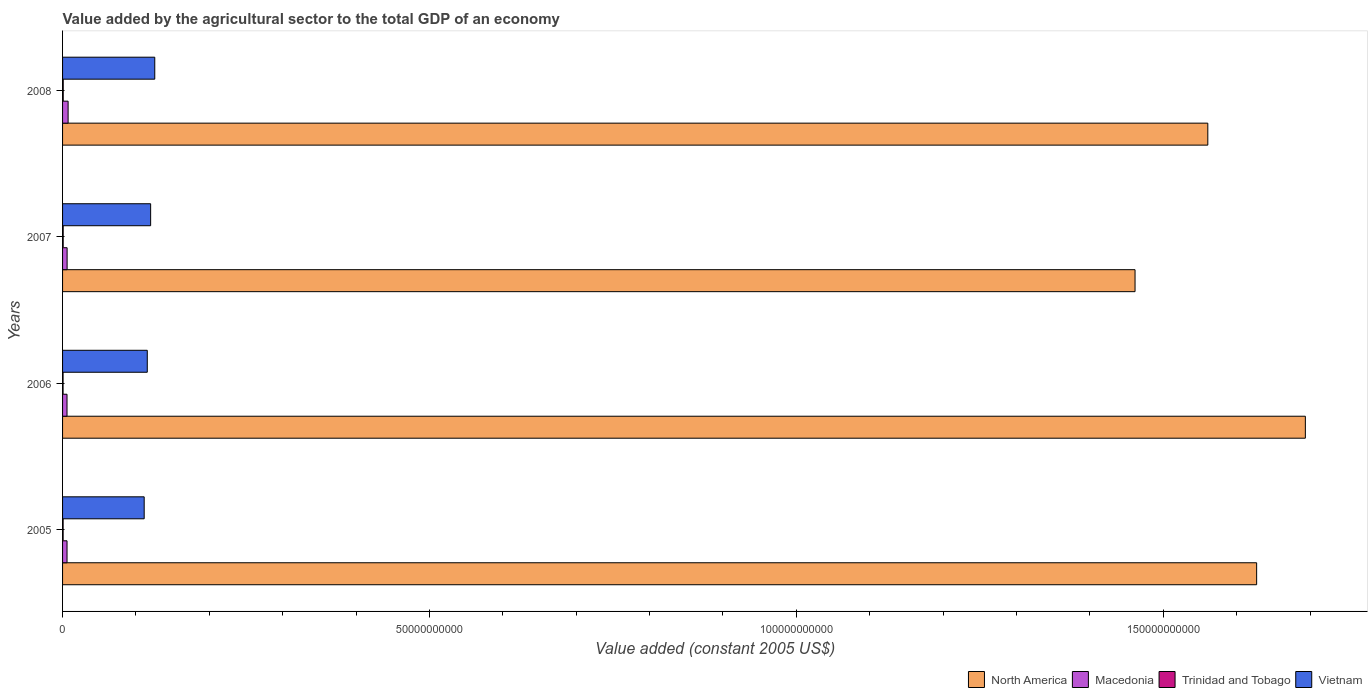How many groups of bars are there?
Keep it short and to the point. 4. Are the number of bars on each tick of the Y-axis equal?
Provide a short and direct response. Yes. How many bars are there on the 3rd tick from the bottom?
Offer a very short reply. 4. What is the label of the 4th group of bars from the top?
Your answer should be very brief. 2005. What is the value added by the agricultural sector in Vietnam in 2008?
Ensure brevity in your answer.  1.26e+1. Across all years, what is the maximum value added by the agricultural sector in Trinidad and Tobago?
Provide a succinct answer. 9.12e+07. Across all years, what is the minimum value added by the agricultural sector in Macedonia?
Keep it short and to the point. 6.06e+08. What is the total value added by the agricultural sector in Trinidad and Tobago in the graph?
Provide a succinct answer. 3.23e+08. What is the difference between the value added by the agricultural sector in Trinidad and Tobago in 2005 and that in 2008?
Provide a short and direct response. -1.39e+07. What is the difference between the value added by the agricultural sector in North America in 2006 and the value added by the agricultural sector in Trinidad and Tobago in 2008?
Your response must be concise. 1.69e+11. What is the average value added by the agricultural sector in Trinidad and Tobago per year?
Your response must be concise. 8.07e+07. In the year 2007, what is the difference between the value added by the agricultural sector in Trinidad and Tobago and value added by the agricultural sector in Vietnam?
Your answer should be compact. -1.19e+1. In how many years, is the value added by the agricultural sector in Trinidad and Tobago greater than 80000000000 US$?
Keep it short and to the point. 0. What is the ratio of the value added by the agricultural sector in North America in 2005 to that in 2007?
Offer a very short reply. 1.11. Is the value added by the agricultural sector in Macedonia in 2005 less than that in 2007?
Keep it short and to the point. Yes. What is the difference between the highest and the second highest value added by the agricultural sector in North America?
Offer a terse response. 6.64e+09. What is the difference between the highest and the lowest value added by the agricultural sector in Macedonia?
Offer a terse response. 1.49e+08. In how many years, is the value added by the agricultural sector in North America greater than the average value added by the agricultural sector in North America taken over all years?
Give a very brief answer. 2. Is the sum of the value added by the agricultural sector in Vietnam in 2006 and 2008 greater than the maximum value added by the agricultural sector in North America across all years?
Give a very brief answer. No. What does the 2nd bar from the top in 2006 represents?
Your answer should be very brief. Trinidad and Tobago. What does the 3rd bar from the bottom in 2008 represents?
Give a very brief answer. Trinidad and Tobago. Is it the case that in every year, the sum of the value added by the agricultural sector in North America and value added by the agricultural sector in Macedonia is greater than the value added by the agricultural sector in Trinidad and Tobago?
Make the answer very short. Yes. How many years are there in the graph?
Provide a short and direct response. 4. What is the difference between two consecutive major ticks on the X-axis?
Offer a very short reply. 5.00e+1. Does the graph contain any zero values?
Give a very brief answer. No. Does the graph contain grids?
Make the answer very short. No. How are the legend labels stacked?
Your response must be concise. Horizontal. What is the title of the graph?
Your answer should be very brief. Value added by the agricultural sector to the total GDP of an economy. Does "Antigua and Barbuda" appear as one of the legend labels in the graph?
Offer a very short reply. No. What is the label or title of the X-axis?
Offer a terse response. Value added (constant 2005 US$). What is the label or title of the Y-axis?
Your response must be concise. Years. What is the Value added (constant 2005 US$) of North America in 2005?
Your answer should be compact. 1.63e+11. What is the Value added (constant 2005 US$) in Macedonia in 2005?
Your answer should be compact. 6.09e+08. What is the Value added (constant 2005 US$) of Trinidad and Tobago in 2005?
Offer a very short reply. 7.73e+07. What is the Value added (constant 2005 US$) of Vietnam in 2005?
Provide a succinct answer. 1.11e+1. What is the Value added (constant 2005 US$) of North America in 2006?
Your answer should be very brief. 1.69e+11. What is the Value added (constant 2005 US$) of Macedonia in 2006?
Make the answer very short. 6.06e+08. What is the Value added (constant 2005 US$) of Trinidad and Tobago in 2006?
Provide a succinct answer. 6.96e+07. What is the Value added (constant 2005 US$) of Vietnam in 2006?
Give a very brief answer. 1.15e+1. What is the Value added (constant 2005 US$) of North America in 2007?
Provide a succinct answer. 1.46e+11. What is the Value added (constant 2005 US$) of Macedonia in 2007?
Offer a terse response. 6.19e+08. What is the Value added (constant 2005 US$) in Trinidad and Tobago in 2007?
Keep it short and to the point. 8.48e+07. What is the Value added (constant 2005 US$) of Vietnam in 2007?
Your answer should be compact. 1.20e+1. What is the Value added (constant 2005 US$) in North America in 2008?
Give a very brief answer. 1.56e+11. What is the Value added (constant 2005 US$) of Macedonia in 2008?
Your response must be concise. 7.55e+08. What is the Value added (constant 2005 US$) in Trinidad and Tobago in 2008?
Offer a very short reply. 9.12e+07. What is the Value added (constant 2005 US$) of Vietnam in 2008?
Your response must be concise. 1.26e+1. Across all years, what is the maximum Value added (constant 2005 US$) in North America?
Offer a very short reply. 1.69e+11. Across all years, what is the maximum Value added (constant 2005 US$) of Macedonia?
Ensure brevity in your answer.  7.55e+08. Across all years, what is the maximum Value added (constant 2005 US$) in Trinidad and Tobago?
Your answer should be compact. 9.12e+07. Across all years, what is the maximum Value added (constant 2005 US$) in Vietnam?
Provide a succinct answer. 1.26e+1. Across all years, what is the minimum Value added (constant 2005 US$) in North America?
Offer a terse response. 1.46e+11. Across all years, what is the minimum Value added (constant 2005 US$) of Macedonia?
Keep it short and to the point. 6.06e+08. Across all years, what is the minimum Value added (constant 2005 US$) in Trinidad and Tobago?
Offer a terse response. 6.96e+07. Across all years, what is the minimum Value added (constant 2005 US$) of Vietnam?
Offer a terse response. 1.11e+1. What is the total Value added (constant 2005 US$) of North America in the graph?
Your answer should be compact. 6.34e+11. What is the total Value added (constant 2005 US$) of Macedonia in the graph?
Offer a very short reply. 2.59e+09. What is the total Value added (constant 2005 US$) of Trinidad and Tobago in the graph?
Ensure brevity in your answer.  3.23e+08. What is the total Value added (constant 2005 US$) of Vietnam in the graph?
Provide a short and direct response. 4.72e+1. What is the difference between the Value added (constant 2005 US$) of North America in 2005 and that in 2006?
Provide a short and direct response. -6.64e+09. What is the difference between the Value added (constant 2005 US$) of Macedonia in 2005 and that in 2006?
Your answer should be compact. 3.31e+06. What is the difference between the Value added (constant 2005 US$) of Trinidad and Tobago in 2005 and that in 2006?
Your response must be concise. 7.66e+06. What is the difference between the Value added (constant 2005 US$) in Vietnam in 2005 and that in 2006?
Your answer should be compact. -4.22e+08. What is the difference between the Value added (constant 2005 US$) in North America in 2005 and that in 2007?
Offer a very short reply. 1.66e+1. What is the difference between the Value added (constant 2005 US$) in Macedonia in 2005 and that in 2007?
Your answer should be very brief. -9.75e+06. What is the difference between the Value added (constant 2005 US$) of Trinidad and Tobago in 2005 and that in 2007?
Keep it short and to the point. -7.48e+06. What is the difference between the Value added (constant 2005 US$) in Vietnam in 2005 and that in 2007?
Your answer should be compact. -8.79e+08. What is the difference between the Value added (constant 2005 US$) in North America in 2005 and that in 2008?
Your answer should be very brief. 6.65e+09. What is the difference between the Value added (constant 2005 US$) in Macedonia in 2005 and that in 2008?
Offer a very short reply. -1.46e+08. What is the difference between the Value added (constant 2005 US$) in Trinidad and Tobago in 2005 and that in 2008?
Provide a short and direct response. -1.39e+07. What is the difference between the Value added (constant 2005 US$) in Vietnam in 2005 and that in 2008?
Your response must be concise. -1.44e+09. What is the difference between the Value added (constant 2005 US$) in North America in 2006 and that in 2007?
Offer a very short reply. 2.32e+1. What is the difference between the Value added (constant 2005 US$) of Macedonia in 2006 and that in 2007?
Give a very brief answer. -1.31e+07. What is the difference between the Value added (constant 2005 US$) of Trinidad and Tobago in 2006 and that in 2007?
Offer a terse response. -1.51e+07. What is the difference between the Value added (constant 2005 US$) in Vietnam in 2006 and that in 2007?
Provide a short and direct response. -4.57e+08. What is the difference between the Value added (constant 2005 US$) of North America in 2006 and that in 2008?
Offer a terse response. 1.33e+1. What is the difference between the Value added (constant 2005 US$) in Macedonia in 2006 and that in 2008?
Provide a short and direct response. -1.49e+08. What is the difference between the Value added (constant 2005 US$) in Trinidad and Tobago in 2006 and that in 2008?
Keep it short and to the point. -2.16e+07. What is the difference between the Value added (constant 2005 US$) in Vietnam in 2006 and that in 2008?
Provide a short and direct response. -1.02e+09. What is the difference between the Value added (constant 2005 US$) of North America in 2007 and that in 2008?
Ensure brevity in your answer.  -9.92e+09. What is the difference between the Value added (constant 2005 US$) of Macedonia in 2007 and that in 2008?
Provide a short and direct response. -1.36e+08. What is the difference between the Value added (constant 2005 US$) in Trinidad and Tobago in 2007 and that in 2008?
Provide a succinct answer. -6.41e+06. What is the difference between the Value added (constant 2005 US$) of Vietnam in 2007 and that in 2008?
Keep it short and to the point. -5.63e+08. What is the difference between the Value added (constant 2005 US$) in North America in 2005 and the Value added (constant 2005 US$) in Macedonia in 2006?
Your response must be concise. 1.62e+11. What is the difference between the Value added (constant 2005 US$) in North America in 2005 and the Value added (constant 2005 US$) in Trinidad and Tobago in 2006?
Give a very brief answer. 1.63e+11. What is the difference between the Value added (constant 2005 US$) in North America in 2005 and the Value added (constant 2005 US$) in Vietnam in 2006?
Give a very brief answer. 1.51e+11. What is the difference between the Value added (constant 2005 US$) of Macedonia in 2005 and the Value added (constant 2005 US$) of Trinidad and Tobago in 2006?
Your response must be concise. 5.40e+08. What is the difference between the Value added (constant 2005 US$) of Macedonia in 2005 and the Value added (constant 2005 US$) of Vietnam in 2006?
Your answer should be very brief. -1.09e+1. What is the difference between the Value added (constant 2005 US$) of Trinidad and Tobago in 2005 and the Value added (constant 2005 US$) of Vietnam in 2006?
Your response must be concise. -1.15e+1. What is the difference between the Value added (constant 2005 US$) in North America in 2005 and the Value added (constant 2005 US$) in Macedonia in 2007?
Offer a terse response. 1.62e+11. What is the difference between the Value added (constant 2005 US$) in North America in 2005 and the Value added (constant 2005 US$) in Trinidad and Tobago in 2007?
Give a very brief answer. 1.63e+11. What is the difference between the Value added (constant 2005 US$) of North America in 2005 and the Value added (constant 2005 US$) of Vietnam in 2007?
Your answer should be very brief. 1.51e+11. What is the difference between the Value added (constant 2005 US$) of Macedonia in 2005 and the Value added (constant 2005 US$) of Trinidad and Tobago in 2007?
Your answer should be very brief. 5.25e+08. What is the difference between the Value added (constant 2005 US$) in Macedonia in 2005 and the Value added (constant 2005 US$) in Vietnam in 2007?
Offer a terse response. -1.14e+1. What is the difference between the Value added (constant 2005 US$) of Trinidad and Tobago in 2005 and the Value added (constant 2005 US$) of Vietnam in 2007?
Ensure brevity in your answer.  -1.19e+1. What is the difference between the Value added (constant 2005 US$) of North America in 2005 and the Value added (constant 2005 US$) of Macedonia in 2008?
Offer a very short reply. 1.62e+11. What is the difference between the Value added (constant 2005 US$) of North America in 2005 and the Value added (constant 2005 US$) of Trinidad and Tobago in 2008?
Provide a succinct answer. 1.63e+11. What is the difference between the Value added (constant 2005 US$) of North America in 2005 and the Value added (constant 2005 US$) of Vietnam in 2008?
Keep it short and to the point. 1.50e+11. What is the difference between the Value added (constant 2005 US$) of Macedonia in 2005 and the Value added (constant 2005 US$) of Trinidad and Tobago in 2008?
Make the answer very short. 5.18e+08. What is the difference between the Value added (constant 2005 US$) of Macedonia in 2005 and the Value added (constant 2005 US$) of Vietnam in 2008?
Give a very brief answer. -1.20e+1. What is the difference between the Value added (constant 2005 US$) of Trinidad and Tobago in 2005 and the Value added (constant 2005 US$) of Vietnam in 2008?
Keep it short and to the point. -1.25e+1. What is the difference between the Value added (constant 2005 US$) of North America in 2006 and the Value added (constant 2005 US$) of Macedonia in 2007?
Your response must be concise. 1.69e+11. What is the difference between the Value added (constant 2005 US$) of North America in 2006 and the Value added (constant 2005 US$) of Trinidad and Tobago in 2007?
Ensure brevity in your answer.  1.69e+11. What is the difference between the Value added (constant 2005 US$) in North America in 2006 and the Value added (constant 2005 US$) in Vietnam in 2007?
Your answer should be very brief. 1.57e+11. What is the difference between the Value added (constant 2005 US$) of Macedonia in 2006 and the Value added (constant 2005 US$) of Trinidad and Tobago in 2007?
Give a very brief answer. 5.21e+08. What is the difference between the Value added (constant 2005 US$) of Macedonia in 2006 and the Value added (constant 2005 US$) of Vietnam in 2007?
Give a very brief answer. -1.14e+1. What is the difference between the Value added (constant 2005 US$) in Trinidad and Tobago in 2006 and the Value added (constant 2005 US$) in Vietnam in 2007?
Your response must be concise. -1.19e+1. What is the difference between the Value added (constant 2005 US$) in North America in 2006 and the Value added (constant 2005 US$) in Macedonia in 2008?
Your response must be concise. 1.69e+11. What is the difference between the Value added (constant 2005 US$) in North America in 2006 and the Value added (constant 2005 US$) in Trinidad and Tobago in 2008?
Offer a terse response. 1.69e+11. What is the difference between the Value added (constant 2005 US$) of North America in 2006 and the Value added (constant 2005 US$) of Vietnam in 2008?
Offer a very short reply. 1.57e+11. What is the difference between the Value added (constant 2005 US$) of Macedonia in 2006 and the Value added (constant 2005 US$) of Trinidad and Tobago in 2008?
Your response must be concise. 5.15e+08. What is the difference between the Value added (constant 2005 US$) of Macedonia in 2006 and the Value added (constant 2005 US$) of Vietnam in 2008?
Your response must be concise. -1.20e+1. What is the difference between the Value added (constant 2005 US$) of Trinidad and Tobago in 2006 and the Value added (constant 2005 US$) of Vietnam in 2008?
Provide a short and direct response. -1.25e+1. What is the difference between the Value added (constant 2005 US$) in North America in 2007 and the Value added (constant 2005 US$) in Macedonia in 2008?
Your answer should be very brief. 1.45e+11. What is the difference between the Value added (constant 2005 US$) in North America in 2007 and the Value added (constant 2005 US$) in Trinidad and Tobago in 2008?
Keep it short and to the point. 1.46e+11. What is the difference between the Value added (constant 2005 US$) in North America in 2007 and the Value added (constant 2005 US$) in Vietnam in 2008?
Provide a short and direct response. 1.34e+11. What is the difference between the Value added (constant 2005 US$) in Macedonia in 2007 and the Value added (constant 2005 US$) in Trinidad and Tobago in 2008?
Your answer should be compact. 5.28e+08. What is the difference between the Value added (constant 2005 US$) of Macedonia in 2007 and the Value added (constant 2005 US$) of Vietnam in 2008?
Ensure brevity in your answer.  -1.19e+1. What is the difference between the Value added (constant 2005 US$) of Trinidad and Tobago in 2007 and the Value added (constant 2005 US$) of Vietnam in 2008?
Give a very brief answer. -1.25e+1. What is the average Value added (constant 2005 US$) in North America per year?
Your answer should be compact. 1.59e+11. What is the average Value added (constant 2005 US$) in Macedonia per year?
Offer a very short reply. 6.47e+08. What is the average Value added (constant 2005 US$) of Trinidad and Tobago per year?
Offer a terse response. 8.07e+07. What is the average Value added (constant 2005 US$) in Vietnam per year?
Provide a succinct answer. 1.18e+1. In the year 2005, what is the difference between the Value added (constant 2005 US$) of North America and Value added (constant 2005 US$) of Macedonia?
Your answer should be very brief. 1.62e+11. In the year 2005, what is the difference between the Value added (constant 2005 US$) in North America and Value added (constant 2005 US$) in Trinidad and Tobago?
Keep it short and to the point. 1.63e+11. In the year 2005, what is the difference between the Value added (constant 2005 US$) of North America and Value added (constant 2005 US$) of Vietnam?
Offer a terse response. 1.52e+11. In the year 2005, what is the difference between the Value added (constant 2005 US$) of Macedonia and Value added (constant 2005 US$) of Trinidad and Tobago?
Your answer should be compact. 5.32e+08. In the year 2005, what is the difference between the Value added (constant 2005 US$) of Macedonia and Value added (constant 2005 US$) of Vietnam?
Offer a terse response. -1.05e+1. In the year 2005, what is the difference between the Value added (constant 2005 US$) of Trinidad and Tobago and Value added (constant 2005 US$) of Vietnam?
Your answer should be compact. -1.10e+1. In the year 2006, what is the difference between the Value added (constant 2005 US$) of North America and Value added (constant 2005 US$) of Macedonia?
Make the answer very short. 1.69e+11. In the year 2006, what is the difference between the Value added (constant 2005 US$) of North America and Value added (constant 2005 US$) of Trinidad and Tobago?
Your answer should be compact. 1.69e+11. In the year 2006, what is the difference between the Value added (constant 2005 US$) of North America and Value added (constant 2005 US$) of Vietnam?
Provide a short and direct response. 1.58e+11. In the year 2006, what is the difference between the Value added (constant 2005 US$) in Macedonia and Value added (constant 2005 US$) in Trinidad and Tobago?
Your answer should be very brief. 5.36e+08. In the year 2006, what is the difference between the Value added (constant 2005 US$) in Macedonia and Value added (constant 2005 US$) in Vietnam?
Your answer should be very brief. -1.09e+1. In the year 2006, what is the difference between the Value added (constant 2005 US$) in Trinidad and Tobago and Value added (constant 2005 US$) in Vietnam?
Keep it short and to the point. -1.15e+1. In the year 2007, what is the difference between the Value added (constant 2005 US$) in North America and Value added (constant 2005 US$) in Macedonia?
Your response must be concise. 1.46e+11. In the year 2007, what is the difference between the Value added (constant 2005 US$) of North America and Value added (constant 2005 US$) of Trinidad and Tobago?
Your answer should be compact. 1.46e+11. In the year 2007, what is the difference between the Value added (constant 2005 US$) of North America and Value added (constant 2005 US$) of Vietnam?
Make the answer very short. 1.34e+11. In the year 2007, what is the difference between the Value added (constant 2005 US$) of Macedonia and Value added (constant 2005 US$) of Trinidad and Tobago?
Give a very brief answer. 5.34e+08. In the year 2007, what is the difference between the Value added (constant 2005 US$) of Macedonia and Value added (constant 2005 US$) of Vietnam?
Your answer should be compact. -1.14e+1. In the year 2007, what is the difference between the Value added (constant 2005 US$) of Trinidad and Tobago and Value added (constant 2005 US$) of Vietnam?
Offer a terse response. -1.19e+1. In the year 2008, what is the difference between the Value added (constant 2005 US$) in North America and Value added (constant 2005 US$) in Macedonia?
Your answer should be very brief. 1.55e+11. In the year 2008, what is the difference between the Value added (constant 2005 US$) of North America and Value added (constant 2005 US$) of Trinidad and Tobago?
Your response must be concise. 1.56e+11. In the year 2008, what is the difference between the Value added (constant 2005 US$) in North America and Value added (constant 2005 US$) in Vietnam?
Give a very brief answer. 1.44e+11. In the year 2008, what is the difference between the Value added (constant 2005 US$) of Macedonia and Value added (constant 2005 US$) of Trinidad and Tobago?
Provide a short and direct response. 6.64e+08. In the year 2008, what is the difference between the Value added (constant 2005 US$) of Macedonia and Value added (constant 2005 US$) of Vietnam?
Your answer should be very brief. -1.18e+1. In the year 2008, what is the difference between the Value added (constant 2005 US$) in Trinidad and Tobago and Value added (constant 2005 US$) in Vietnam?
Keep it short and to the point. -1.25e+1. What is the ratio of the Value added (constant 2005 US$) of North America in 2005 to that in 2006?
Ensure brevity in your answer.  0.96. What is the ratio of the Value added (constant 2005 US$) in Macedonia in 2005 to that in 2006?
Provide a short and direct response. 1.01. What is the ratio of the Value added (constant 2005 US$) in Trinidad and Tobago in 2005 to that in 2006?
Your answer should be very brief. 1.11. What is the ratio of the Value added (constant 2005 US$) in Vietnam in 2005 to that in 2006?
Your answer should be very brief. 0.96. What is the ratio of the Value added (constant 2005 US$) of North America in 2005 to that in 2007?
Give a very brief answer. 1.11. What is the ratio of the Value added (constant 2005 US$) of Macedonia in 2005 to that in 2007?
Give a very brief answer. 0.98. What is the ratio of the Value added (constant 2005 US$) in Trinidad and Tobago in 2005 to that in 2007?
Keep it short and to the point. 0.91. What is the ratio of the Value added (constant 2005 US$) in Vietnam in 2005 to that in 2007?
Provide a short and direct response. 0.93. What is the ratio of the Value added (constant 2005 US$) in North America in 2005 to that in 2008?
Ensure brevity in your answer.  1.04. What is the ratio of the Value added (constant 2005 US$) of Macedonia in 2005 to that in 2008?
Make the answer very short. 0.81. What is the ratio of the Value added (constant 2005 US$) in Trinidad and Tobago in 2005 to that in 2008?
Your response must be concise. 0.85. What is the ratio of the Value added (constant 2005 US$) of Vietnam in 2005 to that in 2008?
Offer a terse response. 0.89. What is the ratio of the Value added (constant 2005 US$) in North America in 2006 to that in 2007?
Offer a very short reply. 1.16. What is the ratio of the Value added (constant 2005 US$) in Macedonia in 2006 to that in 2007?
Ensure brevity in your answer.  0.98. What is the ratio of the Value added (constant 2005 US$) in Trinidad and Tobago in 2006 to that in 2007?
Offer a very short reply. 0.82. What is the ratio of the Value added (constant 2005 US$) of North America in 2006 to that in 2008?
Give a very brief answer. 1.09. What is the ratio of the Value added (constant 2005 US$) of Macedonia in 2006 to that in 2008?
Your answer should be very brief. 0.8. What is the ratio of the Value added (constant 2005 US$) in Trinidad and Tobago in 2006 to that in 2008?
Your response must be concise. 0.76. What is the ratio of the Value added (constant 2005 US$) of Vietnam in 2006 to that in 2008?
Offer a terse response. 0.92. What is the ratio of the Value added (constant 2005 US$) in North America in 2007 to that in 2008?
Offer a very short reply. 0.94. What is the ratio of the Value added (constant 2005 US$) of Macedonia in 2007 to that in 2008?
Ensure brevity in your answer.  0.82. What is the ratio of the Value added (constant 2005 US$) in Trinidad and Tobago in 2007 to that in 2008?
Your response must be concise. 0.93. What is the ratio of the Value added (constant 2005 US$) of Vietnam in 2007 to that in 2008?
Your response must be concise. 0.96. What is the difference between the highest and the second highest Value added (constant 2005 US$) in North America?
Provide a short and direct response. 6.64e+09. What is the difference between the highest and the second highest Value added (constant 2005 US$) of Macedonia?
Your answer should be very brief. 1.36e+08. What is the difference between the highest and the second highest Value added (constant 2005 US$) in Trinidad and Tobago?
Offer a terse response. 6.41e+06. What is the difference between the highest and the second highest Value added (constant 2005 US$) in Vietnam?
Provide a short and direct response. 5.63e+08. What is the difference between the highest and the lowest Value added (constant 2005 US$) in North America?
Your answer should be compact. 2.32e+1. What is the difference between the highest and the lowest Value added (constant 2005 US$) in Macedonia?
Your response must be concise. 1.49e+08. What is the difference between the highest and the lowest Value added (constant 2005 US$) in Trinidad and Tobago?
Provide a short and direct response. 2.16e+07. What is the difference between the highest and the lowest Value added (constant 2005 US$) in Vietnam?
Give a very brief answer. 1.44e+09. 